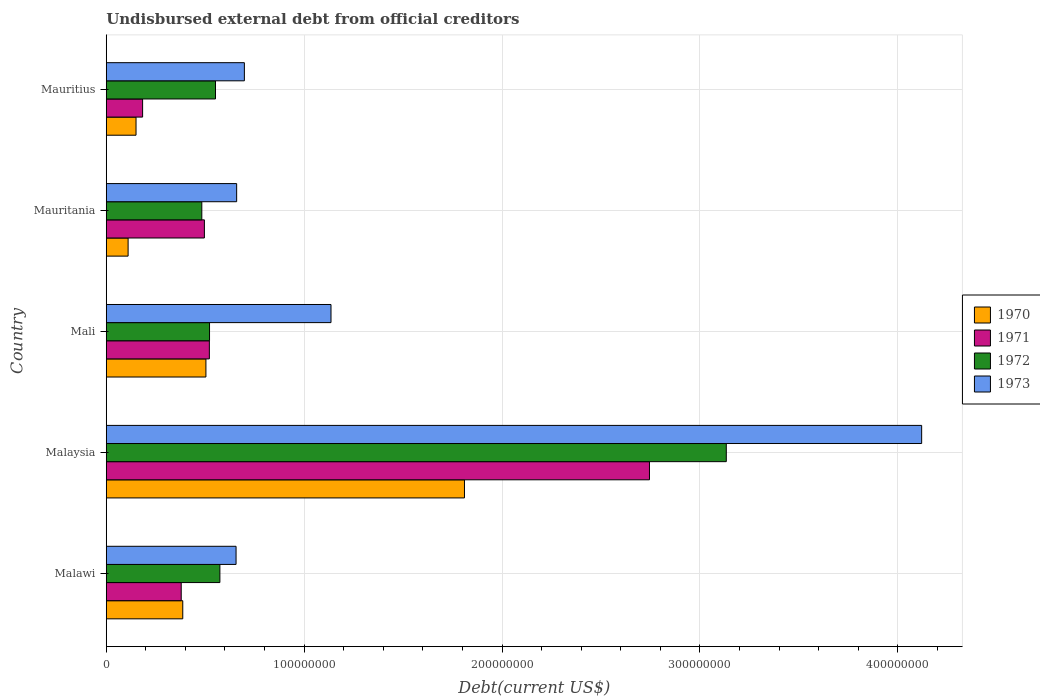How many different coloured bars are there?
Make the answer very short. 4. Are the number of bars per tick equal to the number of legend labels?
Offer a terse response. Yes. Are the number of bars on each tick of the Y-axis equal?
Provide a succinct answer. Yes. How many bars are there on the 1st tick from the bottom?
Offer a terse response. 4. What is the label of the 1st group of bars from the top?
Give a very brief answer. Mauritius. What is the total debt in 1970 in Mauritania?
Provide a succinct answer. 1.10e+07. Across all countries, what is the maximum total debt in 1970?
Give a very brief answer. 1.81e+08. Across all countries, what is the minimum total debt in 1971?
Keep it short and to the point. 1.84e+07. In which country was the total debt in 1973 maximum?
Your answer should be very brief. Malaysia. In which country was the total debt in 1971 minimum?
Your answer should be very brief. Mauritius. What is the total total debt in 1970 in the graph?
Your answer should be very brief. 2.96e+08. What is the difference between the total debt in 1972 in Malawi and that in Mauritius?
Give a very brief answer. 2.22e+06. What is the difference between the total debt in 1971 in Mauritius and the total debt in 1972 in Malawi?
Give a very brief answer. -3.91e+07. What is the average total debt in 1970 per country?
Your answer should be compact. 5.92e+07. What is the difference between the total debt in 1972 and total debt in 1971 in Mauritania?
Your answer should be compact. -1.30e+06. In how many countries, is the total debt in 1970 greater than 120000000 US$?
Offer a very short reply. 1. What is the ratio of the total debt in 1973 in Malawi to that in Malaysia?
Provide a succinct answer. 0.16. Is the total debt in 1973 in Mali less than that in Mauritius?
Provide a succinct answer. No. What is the difference between the highest and the second highest total debt in 1973?
Make the answer very short. 2.98e+08. What is the difference between the highest and the lowest total debt in 1970?
Ensure brevity in your answer.  1.70e+08. In how many countries, is the total debt in 1971 greater than the average total debt in 1971 taken over all countries?
Provide a succinct answer. 1. How many bars are there?
Keep it short and to the point. 20. Are all the bars in the graph horizontal?
Offer a very short reply. Yes. How many countries are there in the graph?
Provide a short and direct response. 5. What is the difference between two consecutive major ticks on the X-axis?
Offer a terse response. 1.00e+08. Are the values on the major ticks of X-axis written in scientific E-notation?
Ensure brevity in your answer.  No. Does the graph contain any zero values?
Provide a succinct answer. No. What is the title of the graph?
Keep it short and to the point. Undisbursed external debt from official creditors. Does "1998" appear as one of the legend labels in the graph?
Ensure brevity in your answer.  No. What is the label or title of the X-axis?
Offer a very short reply. Debt(current US$). What is the label or title of the Y-axis?
Offer a terse response. Country. What is the Debt(current US$) in 1970 in Malawi?
Give a very brief answer. 3.87e+07. What is the Debt(current US$) of 1971 in Malawi?
Keep it short and to the point. 3.79e+07. What is the Debt(current US$) in 1972 in Malawi?
Provide a short and direct response. 5.74e+07. What is the Debt(current US$) of 1973 in Malawi?
Offer a very short reply. 6.56e+07. What is the Debt(current US$) in 1970 in Malaysia?
Keep it short and to the point. 1.81e+08. What is the Debt(current US$) in 1971 in Malaysia?
Your answer should be very brief. 2.74e+08. What is the Debt(current US$) of 1972 in Malaysia?
Your answer should be very brief. 3.13e+08. What is the Debt(current US$) of 1973 in Malaysia?
Provide a succinct answer. 4.12e+08. What is the Debt(current US$) of 1970 in Mali?
Offer a terse response. 5.04e+07. What is the Debt(current US$) in 1971 in Mali?
Offer a very short reply. 5.21e+07. What is the Debt(current US$) of 1972 in Mali?
Provide a short and direct response. 5.22e+07. What is the Debt(current US$) in 1973 in Mali?
Your answer should be very brief. 1.14e+08. What is the Debt(current US$) of 1970 in Mauritania?
Provide a succinct answer. 1.10e+07. What is the Debt(current US$) in 1971 in Mauritania?
Your response must be concise. 4.96e+07. What is the Debt(current US$) of 1972 in Mauritania?
Ensure brevity in your answer.  4.83e+07. What is the Debt(current US$) of 1973 in Mauritania?
Give a very brief answer. 6.59e+07. What is the Debt(current US$) of 1970 in Mauritius?
Offer a very short reply. 1.50e+07. What is the Debt(current US$) of 1971 in Mauritius?
Ensure brevity in your answer.  1.84e+07. What is the Debt(current US$) of 1972 in Mauritius?
Give a very brief answer. 5.52e+07. What is the Debt(current US$) in 1973 in Mauritius?
Make the answer very short. 6.98e+07. Across all countries, what is the maximum Debt(current US$) of 1970?
Provide a succinct answer. 1.81e+08. Across all countries, what is the maximum Debt(current US$) in 1971?
Your response must be concise. 2.74e+08. Across all countries, what is the maximum Debt(current US$) in 1972?
Offer a terse response. 3.13e+08. Across all countries, what is the maximum Debt(current US$) of 1973?
Ensure brevity in your answer.  4.12e+08. Across all countries, what is the minimum Debt(current US$) of 1970?
Keep it short and to the point. 1.10e+07. Across all countries, what is the minimum Debt(current US$) of 1971?
Provide a succinct answer. 1.84e+07. Across all countries, what is the minimum Debt(current US$) in 1972?
Provide a succinct answer. 4.83e+07. Across all countries, what is the minimum Debt(current US$) in 1973?
Give a very brief answer. 6.56e+07. What is the total Debt(current US$) of 1970 in the graph?
Your response must be concise. 2.96e+08. What is the total Debt(current US$) of 1971 in the graph?
Your response must be concise. 4.32e+08. What is the total Debt(current US$) of 1972 in the graph?
Give a very brief answer. 5.26e+08. What is the total Debt(current US$) of 1973 in the graph?
Your answer should be compact. 7.27e+08. What is the difference between the Debt(current US$) in 1970 in Malawi and that in Malaysia?
Provide a succinct answer. -1.42e+08. What is the difference between the Debt(current US$) of 1971 in Malawi and that in Malaysia?
Ensure brevity in your answer.  -2.37e+08. What is the difference between the Debt(current US$) of 1972 in Malawi and that in Malaysia?
Ensure brevity in your answer.  -2.56e+08. What is the difference between the Debt(current US$) of 1973 in Malawi and that in Malaysia?
Offer a terse response. -3.46e+08. What is the difference between the Debt(current US$) of 1970 in Malawi and that in Mali?
Your answer should be compact. -1.17e+07. What is the difference between the Debt(current US$) in 1971 in Malawi and that in Mali?
Ensure brevity in your answer.  -1.42e+07. What is the difference between the Debt(current US$) of 1972 in Malawi and that in Mali?
Offer a terse response. 5.24e+06. What is the difference between the Debt(current US$) in 1973 in Malawi and that in Mali?
Ensure brevity in your answer.  -4.80e+07. What is the difference between the Debt(current US$) of 1970 in Malawi and that in Mauritania?
Offer a very short reply. 2.76e+07. What is the difference between the Debt(current US$) of 1971 in Malawi and that in Mauritania?
Give a very brief answer. -1.17e+07. What is the difference between the Debt(current US$) in 1972 in Malawi and that in Mauritania?
Your answer should be compact. 9.13e+06. What is the difference between the Debt(current US$) in 1973 in Malawi and that in Mauritania?
Your answer should be very brief. -3.01e+05. What is the difference between the Debt(current US$) of 1970 in Malawi and that in Mauritius?
Your response must be concise. 2.36e+07. What is the difference between the Debt(current US$) in 1971 in Malawi and that in Mauritius?
Provide a short and direct response. 1.95e+07. What is the difference between the Debt(current US$) in 1972 in Malawi and that in Mauritius?
Provide a succinct answer. 2.22e+06. What is the difference between the Debt(current US$) in 1973 in Malawi and that in Mauritius?
Your answer should be very brief. -4.20e+06. What is the difference between the Debt(current US$) of 1970 in Malaysia and that in Mali?
Ensure brevity in your answer.  1.31e+08. What is the difference between the Debt(current US$) of 1971 in Malaysia and that in Mali?
Keep it short and to the point. 2.22e+08. What is the difference between the Debt(current US$) in 1972 in Malaysia and that in Mali?
Give a very brief answer. 2.61e+08. What is the difference between the Debt(current US$) in 1973 in Malaysia and that in Mali?
Offer a terse response. 2.98e+08. What is the difference between the Debt(current US$) of 1970 in Malaysia and that in Mauritania?
Provide a succinct answer. 1.70e+08. What is the difference between the Debt(current US$) of 1971 in Malaysia and that in Mauritania?
Provide a short and direct response. 2.25e+08. What is the difference between the Debt(current US$) of 1972 in Malaysia and that in Mauritania?
Your answer should be very brief. 2.65e+08. What is the difference between the Debt(current US$) in 1973 in Malaysia and that in Mauritania?
Provide a short and direct response. 3.46e+08. What is the difference between the Debt(current US$) in 1970 in Malaysia and that in Mauritius?
Offer a terse response. 1.66e+08. What is the difference between the Debt(current US$) of 1971 in Malaysia and that in Mauritius?
Provide a short and direct response. 2.56e+08. What is the difference between the Debt(current US$) in 1972 in Malaysia and that in Mauritius?
Make the answer very short. 2.58e+08. What is the difference between the Debt(current US$) in 1973 in Malaysia and that in Mauritius?
Your answer should be very brief. 3.42e+08. What is the difference between the Debt(current US$) of 1970 in Mali and that in Mauritania?
Your answer should be very brief. 3.93e+07. What is the difference between the Debt(current US$) in 1971 in Mali and that in Mauritania?
Provide a succinct answer. 2.51e+06. What is the difference between the Debt(current US$) in 1972 in Mali and that in Mauritania?
Keep it short and to the point. 3.90e+06. What is the difference between the Debt(current US$) of 1973 in Mali and that in Mauritania?
Make the answer very short. 4.77e+07. What is the difference between the Debt(current US$) of 1970 in Mali and that in Mauritius?
Your answer should be very brief. 3.53e+07. What is the difference between the Debt(current US$) of 1971 in Mali and that in Mauritius?
Give a very brief answer. 3.37e+07. What is the difference between the Debt(current US$) in 1972 in Mali and that in Mauritius?
Make the answer very short. -3.02e+06. What is the difference between the Debt(current US$) of 1973 in Mali and that in Mauritius?
Your answer should be compact. 4.38e+07. What is the difference between the Debt(current US$) in 1970 in Mauritania and that in Mauritius?
Your answer should be very brief. -4.00e+06. What is the difference between the Debt(current US$) of 1971 in Mauritania and that in Mauritius?
Your answer should be very brief. 3.12e+07. What is the difference between the Debt(current US$) in 1972 in Mauritania and that in Mauritius?
Give a very brief answer. -6.91e+06. What is the difference between the Debt(current US$) in 1973 in Mauritania and that in Mauritius?
Offer a terse response. -3.90e+06. What is the difference between the Debt(current US$) in 1970 in Malawi and the Debt(current US$) in 1971 in Malaysia?
Keep it short and to the point. -2.36e+08. What is the difference between the Debt(current US$) in 1970 in Malawi and the Debt(current US$) in 1972 in Malaysia?
Provide a succinct answer. -2.75e+08. What is the difference between the Debt(current US$) of 1970 in Malawi and the Debt(current US$) of 1973 in Malaysia?
Offer a very short reply. -3.73e+08. What is the difference between the Debt(current US$) of 1971 in Malawi and the Debt(current US$) of 1972 in Malaysia?
Give a very brief answer. -2.75e+08. What is the difference between the Debt(current US$) in 1971 in Malawi and the Debt(current US$) in 1973 in Malaysia?
Ensure brevity in your answer.  -3.74e+08. What is the difference between the Debt(current US$) of 1972 in Malawi and the Debt(current US$) of 1973 in Malaysia?
Make the answer very short. -3.55e+08. What is the difference between the Debt(current US$) in 1970 in Malawi and the Debt(current US$) in 1971 in Mali?
Make the answer very short. -1.34e+07. What is the difference between the Debt(current US$) in 1970 in Malawi and the Debt(current US$) in 1972 in Mali?
Your response must be concise. -1.35e+07. What is the difference between the Debt(current US$) in 1970 in Malawi and the Debt(current US$) in 1973 in Mali?
Provide a short and direct response. -7.49e+07. What is the difference between the Debt(current US$) of 1971 in Malawi and the Debt(current US$) of 1972 in Mali?
Offer a very short reply. -1.43e+07. What is the difference between the Debt(current US$) in 1971 in Malawi and the Debt(current US$) in 1973 in Mali?
Provide a short and direct response. -7.57e+07. What is the difference between the Debt(current US$) in 1972 in Malawi and the Debt(current US$) in 1973 in Mali?
Provide a succinct answer. -5.61e+07. What is the difference between the Debt(current US$) in 1970 in Malawi and the Debt(current US$) in 1971 in Mauritania?
Your answer should be very brief. -1.09e+07. What is the difference between the Debt(current US$) in 1970 in Malawi and the Debt(current US$) in 1972 in Mauritania?
Provide a short and direct response. -9.63e+06. What is the difference between the Debt(current US$) in 1970 in Malawi and the Debt(current US$) in 1973 in Mauritania?
Your response must be concise. -2.72e+07. What is the difference between the Debt(current US$) of 1971 in Malawi and the Debt(current US$) of 1972 in Mauritania?
Provide a succinct answer. -1.04e+07. What is the difference between the Debt(current US$) of 1971 in Malawi and the Debt(current US$) of 1973 in Mauritania?
Keep it short and to the point. -2.80e+07. What is the difference between the Debt(current US$) in 1972 in Malawi and the Debt(current US$) in 1973 in Mauritania?
Offer a very short reply. -8.47e+06. What is the difference between the Debt(current US$) of 1970 in Malawi and the Debt(current US$) of 1971 in Mauritius?
Your answer should be compact. 2.03e+07. What is the difference between the Debt(current US$) in 1970 in Malawi and the Debt(current US$) in 1972 in Mauritius?
Give a very brief answer. -1.65e+07. What is the difference between the Debt(current US$) in 1970 in Malawi and the Debt(current US$) in 1973 in Mauritius?
Offer a very short reply. -3.11e+07. What is the difference between the Debt(current US$) of 1971 in Malawi and the Debt(current US$) of 1972 in Mauritius?
Provide a short and direct response. -1.73e+07. What is the difference between the Debt(current US$) of 1971 in Malawi and the Debt(current US$) of 1973 in Mauritius?
Offer a very short reply. -3.19e+07. What is the difference between the Debt(current US$) in 1972 in Malawi and the Debt(current US$) in 1973 in Mauritius?
Give a very brief answer. -1.24e+07. What is the difference between the Debt(current US$) of 1970 in Malaysia and the Debt(current US$) of 1971 in Mali?
Provide a succinct answer. 1.29e+08. What is the difference between the Debt(current US$) in 1970 in Malaysia and the Debt(current US$) in 1972 in Mali?
Your response must be concise. 1.29e+08. What is the difference between the Debt(current US$) in 1970 in Malaysia and the Debt(current US$) in 1973 in Mali?
Ensure brevity in your answer.  6.74e+07. What is the difference between the Debt(current US$) of 1971 in Malaysia and the Debt(current US$) of 1972 in Mali?
Ensure brevity in your answer.  2.22e+08. What is the difference between the Debt(current US$) in 1971 in Malaysia and the Debt(current US$) in 1973 in Mali?
Offer a very short reply. 1.61e+08. What is the difference between the Debt(current US$) of 1972 in Malaysia and the Debt(current US$) of 1973 in Mali?
Give a very brief answer. 2.00e+08. What is the difference between the Debt(current US$) of 1970 in Malaysia and the Debt(current US$) of 1971 in Mauritania?
Ensure brevity in your answer.  1.31e+08. What is the difference between the Debt(current US$) in 1970 in Malaysia and the Debt(current US$) in 1972 in Mauritania?
Give a very brief answer. 1.33e+08. What is the difference between the Debt(current US$) of 1970 in Malaysia and the Debt(current US$) of 1973 in Mauritania?
Your answer should be very brief. 1.15e+08. What is the difference between the Debt(current US$) in 1971 in Malaysia and the Debt(current US$) in 1972 in Mauritania?
Give a very brief answer. 2.26e+08. What is the difference between the Debt(current US$) of 1971 in Malaysia and the Debt(current US$) of 1973 in Mauritania?
Provide a succinct answer. 2.09e+08. What is the difference between the Debt(current US$) in 1972 in Malaysia and the Debt(current US$) in 1973 in Mauritania?
Make the answer very short. 2.47e+08. What is the difference between the Debt(current US$) in 1970 in Malaysia and the Debt(current US$) in 1971 in Mauritius?
Your response must be concise. 1.63e+08. What is the difference between the Debt(current US$) of 1970 in Malaysia and the Debt(current US$) of 1972 in Mauritius?
Ensure brevity in your answer.  1.26e+08. What is the difference between the Debt(current US$) of 1970 in Malaysia and the Debt(current US$) of 1973 in Mauritius?
Your answer should be compact. 1.11e+08. What is the difference between the Debt(current US$) of 1971 in Malaysia and the Debt(current US$) of 1972 in Mauritius?
Provide a succinct answer. 2.19e+08. What is the difference between the Debt(current US$) in 1971 in Malaysia and the Debt(current US$) in 1973 in Mauritius?
Your answer should be compact. 2.05e+08. What is the difference between the Debt(current US$) in 1972 in Malaysia and the Debt(current US$) in 1973 in Mauritius?
Offer a terse response. 2.44e+08. What is the difference between the Debt(current US$) in 1970 in Mali and the Debt(current US$) in 1971 in Mauritania?
Make the answer very short. 7.72e+05. What is the difference between the Debt(current US$) of 1970 in Mali and the Debt(current US$) of 1972 in Mauritania?
Your response must be concise. 2.07e+06. What is the difference between the Debt(current US$) in 1970 in Mali and the Debt(current US$) in 1973 in Mauritania?
Your answer should be very brief. -1.55e+07. What is the difference between the Debt(current US$) of 1971 in Mali and the Debt(current US$) of 1972 in Mauritania?
Offer a terse response. 3.81e+06. What is the difference between the Debt(current US$) of 1971 in Mali and the Debt(current US$) of 1973 in Mauritania?
Your answer should be very brief. -1.38e+07. What is the difference between the Debt(current US$) in 1972 in Mali and the Debt(current US$) in 1973 in Mauritania?
Offer a terse response. -1.37e+07. What is the difference between the Debt(current US$) in 1970 in Mali and the Debt(current US$) in 1971 in Mauritius?
Give a very brief answer. 3.20e+07. What is the difference between the Debt(current US$) of 1970 in Mali and the Debt(current US$) of 1972 in Mauritius?
Give a very brief answer. -4.84e+06. What is the difference between the Debt(current US$) of 1970 in Mali and the Debt(current US$) of 1973 in Mauritius?
Your answer should be compact. -1.94e+07. What is the difference between the Debt(current US$) of 1971 in Mali and the Debt(current US$) of 1972 in Mauritius?
Offer a terse response. -3.10e+06. What is the difference between the Debt(current US$) in 1971 in Mali and the Debt(current US$) in 1973 in Mauritius?
Give a very brief answer. -1.77e+07. What is the difference between the Debt(current US$) of 1972 in Mali and the Debt(current US$) of 1973 in Mauritius?
Provide a succinct answer. -1.76e+07. What is the difference between the Debt(current US$) in 1970 in Mauritania and the Debt(current US$) in 1971 in Mauritius?
Offer a very short reply. -7.33e+06. What is the difference between the Debt(current US$) in 1970 in Mauritania and the Debt(current US$) in 1972 in Mauritius?
Give a very brief answer. -4.42e+07. What is the difference between the Debt(current US$) in 1970 in Mauritania and the Debt(current US$) in 1973 in Mauritius?
Provide a succinct answer. -5.88e+07. What is the difference between the Debt(current US$) of 1971 in Mauritania and the Debt(current US$) of 1972 in Mauritius?
Make the answer very short. -5.62e+06. What is the difference between the Debt(current US$) of 1971 in Mauritania and the Debt(current US$) of 1973 in Mauritius?
Make the answer very short. -2.02e+07. What is the difference between the Debt(current US$) in 1972 in Mauritania and the Debt(current US$) in 1973 in Mauritius?
Give a very brief answer. -2.15e+07. What is the average Debt(current US$) in 1970 per country?
Ensure brevity in your answer.  5.92e+07. What is the average Debt(current US$) of 1971 per country?
Your answer should be very brief. 8.65e+07. What is the average Debt(current US$) of 1972 per country?
Keep it short and to the point. 1.05e+08. What is the average Debt(current US$) of 1973 per country?
Make the answer very short. 1.45e+08. What is the difference between the Debt(current US$) of 1970 and Debt(current US$) of 1971 in Malawi?
Keep it short and to the point. 7.85e+05. What is the difference between the Debt(current US$) of 1970 and Debt(current US$) of 1972 in Malawi?
Your answer should be very brief. -1.88e+07. What is the difference between the Debt(current US$) of 1970 and Debt(current US$) of 1973 in Malawi?
Offer a terse response. -2.69e+07. What is the difference between the Debt(current US$) of 1971 and Debt(current US$) of 1972 in Malawi?
Provide a short and direct response. -1.95e+07. What is the difference between the Debt(current US$) in 1971 and Debt(current US$) in 1973 in Malawi?
Your answer should be very brief. -2.77e+07. What is the difference between the Debt(current US$) in 1972 and Debt(current US$) in 1973 in Malawi?
Offer a very short reply. -8.17e+06. What is the difference between the Debt(current US$) in 1970 and Debt(current US$) in 1971 in Malaysia?
Make the answer very short. -9.35e+07. What is the difference between the Debt(current US$) in 1970 and Debt(current US$) in 1972 in Malaysia?
Offer a very short reply. -1.32e+08. What is the difference between the Debt(current US$) in 1970 and Debt(current US$) in 1973 in Malaysia?
Offer a terse response. -2.31e+08. What is the difference between the Debt(current US$) in 1971 and Debt(current US$) in 1972 in Malaysia?
Make the answer very short. -3.88e+07. What is the difference between the Debt(current US$) of 1971 and Debt(current US$) of 1973 in Malaysia?
Your answer should be compact. -1.38e+08. What is the difference between the Debt(current US$) of 1972 and Debt(current US$) of 1973 in Malaysia?
Offer a very short reply. -9.87e+07. What is the difference between the Debt(current US$) of 1970 and Debt(current US$) of 1971 in Mali?
Keep it short and to the point. -1.74e+06. What is the difference between the Debt(current US$) in 1970 and Debt(current US$) in 1972 in Mali?
Keep it short and to the point. -1.82e+06. What is the difference between the Debt(current US$) of 1970 and Debt(current US$) of 1973 in Mali?
Your response must be concise. -6.32e+07. What is the difference between the Debt(current US$) in 1971 and Debt(current US$) in 1972 in Mali?
Give a very brief answer. -8.30e+04. What is the difference between the Debt(current US$) in 1971 and Debt(current US$) in 1973 in Mali?
Keep it short and to the point. -6.15e+07. What is the difference between the Debt(current US$) of 1972 and Debt(current US$) of 1973 in Mali?
Your response must be concise. -6.14e+07. What is the difference between the Debt(current US$) of 1970 and Debt(current US$) of 1971 in Mauritania?
Provide a short and direct response. -3.85e+07. What is the difference between the Debt(current US$) in 1970 and Debt(current US$) in 1972 in Mauritania?
Make the answer very short. -3.72e+07. What is the difference between the Debt(current US$) of 1970 and Debt(current US$) of 1973 in Mauritania?
Provide a succinct answer. -5.49e+07. What is the difference between the Debt(current US$) in 1971 and Debt(current US$) in 1972 in Mauritania?
Keep it short and to the point. 1.30e+06. What is the difference between the Debt(current US$) in 1971 and Debt(current US$) in 1973 in Mauritania?
Keep it short and to the point. -1.63e+07. What is the difference between the Debt(current US$) of 1972 and Debt(current US$) of 1973 in Mauritania?
Your answer should be compact. -1.76e+07. What is the difference between the Debt(current US$) of 1970 and Debt(current US$) of 1971 in Mauritius?
Give a very brief answer. -3.32e+06. What is the difference between the Debt(current US$) of 1970 and Debt(current US$) of 1972 in Mauritius?
Offer a very short reply. -4.02e+07. What is the difference between the Debt(current US$) of 1970 and Debt(current US$) of 1973 in Mauritius?
Your answer should be compact. -5.47e+07. What is the difference between the Debt(current US$) in 1971 and Debt(current US$) in 1972 in Mauritius?
Your response must be concise. -3.68e+07. What is the difference between the Debt(current US$) in 1971 and Debt(current US$) in 1973 in Mauritius?
Give a very brief answer. -5.14e+07. What is the difference between the Debt(current US$) in 1972 and Debt(current US$) in 1973 in Mauritius?
Ensure brevity in your answer.  -1.46e+07. What is the ratio of the Debt(current US$) in 1970 in Malawi to that in Malaysia?
Make the answer very short. 0.21. What is the ratio of the Debt(current US$) of 1971 in Malawi to that in Malaysia?
Make the answer very short. 0.14. What is the ratio of the Debt(current US$) in 1972 in Malawi to that in Malaysia?
Provide a short and direct response. 0.18. What is the ratio of the Debt(current US$) of 1973 in Malawi to that in Malaysia?
Provide a short and direct response. 0.16. What is the ratio of the Debt(current US$) of 1970 in Malawi to that in Mali?
Offer a terse response. 0.77. What is the ratio of the Debt(current US$) of 1971 in Malawi to that in Mali?
Your response must be concise. 0.73. What is the ratio of the Debt(current US$) in 1972 in Malawi to that in Mali?
Your response must be concise. 1.1. What is the ratio of the Debt(current US$) in 1973 in Malawi to that in Mali?
Provide a short and direct response. 0.58. What is the ratio of the Debt(current US$) in 1970 in Malawi to that in Mauritania?
Your answer should be compact. 3.5. What is the ratio of the Debt(current US$) of 1971 in Malawi to that in Mauritania?
Give a very brief answer. 0.76. What is the ratio of the Debt(current US$) of 1972 in Malawi to that in Mauritania?
Keep it short and to the point. 1.19. What is the ratio of the Debt(current US$) in 1973 in Malawi to that in Mauritania?
Your answer should be compact. 1. What is the ratio of the Debt(current US$) of 1970 in Malawi to that in Mauritius?
Your answer should be very brief. 2.57. What is the ratio of the Debt(current US$) of 1971 in Malawi to that in Mauritius?
Provide a short and direct response. 2.06. What is the ratio of the Debt(current US$) of 1972 in Malawi to that in Mauritius?
Your answer should be very brief. 1.04. What is the ratio of the Debt(current US$) in 1973 in Malawi to that in Mauritius?
Offer a very short reply. 0.94. What is the ratio of the Debt(current US$) of 1970 in Malaysia to that in Mali?
Make the answer very short. 3.59. What is the ratio of the Debt(current US$) of 1971 in Malaysia to that in Mali?
Offer a very short reply. 5.27. What is the ratio of the Debt(current US$) of 1972 in Malaysia to that in Mali?
Provide a short and direct response. 6. What is the ratio of the Debt(current US$) of 1973 in Malaysia to that in Mali?
Your answer should be compact. 3.63. What is the ratio of the Debt(current US$) in 1970 in Malaysia to that in Mauritania?
Ensure brevity in your answer.  16.39. What is the ratio of the Debt(current US$) in 1971 in Malaysia to that in Mauritania?
Provide a succinct answer. 5.54. What is the ratio of the Debt(current US$) of 1972 in Malaysia to that in Mauritania?
Your response must be concise. 6.49. What is the ratio of the Debt(current US$) in 1973 in Malaysia to that in Mauritania?
Give a very brief answer. 6.25. What is the ratio of the Debt(current US$) in 1970 in Malaysia to that in Mauritius?
Your answer should be compact. 12.03. What is the ratio of the Debt(current US$) in 1971 in Malaysia to that in Mauritius?
Your answer should be compact. 14.94. What is the ratio of the Debt(current US$) in 1972 in Malaysia to that in Mauritius?
Your answer should be very brief. 5.68. What is the ratio of the Debt(current US$) in 1973 in Malaysia to that in Mauritius?
Provide a succinct answer. 5.9. What is the ratio of the Debt(current US$) in 1970 in Mali to that in Mauritania?
Ensure brevity in your answer.  4.56. What is the ratio of the Debt(current US$) in 1971 in Mali to that in Mauritania?
Make the answer very short. 1.05. What is the ratio of the Debt(current US$) in 1972 in Mali to that in Mauritania?
Keep it short and to the point. 1.08. What is the ratio of the Debt(current US$) in 1973 in Mali to that in Mauritania?
Keep it short and to the point. 1.72. What is the ratio of the Debt(current US$) of 1970 in Mali to that in Mauritius?
Provide a succinct answer. 3.35. What is the ratio of the Debt(current US$) of 1971 in Mali to that in Mauritius?
Your answer should be very brief. 2.84. What is the ratio of the Debt(current US$) in 1972 in Mali to that in Mauritius?
Make the answer very short. 0.95. What is the ratio of the Debt(current US$) of 1973 in Mali to that in Mauritius?
Provide a short and direct response. 1.63. What is the ratio of the Debt(current US$) in 1970 in Mauritania to that in Mauritius?
Make the answer very short. 0.73. What is the ratio of the Debt(current US$) in 1971 in Mauritania to that in Mauritius?
Offer a terse response. 2.7. What is the ratio of the Debt(current US$) in 1972 in Mauritania to that in Mauritius?
Ensure brevity in your answer.  0.87. What is the ratio of the Debt(current US$) in 1973 in Mauritania to that in Mauritius?
Give a very brief answer. 0.94. What is the difference between the highest and the second highest Debt(current US$) of 1970?
Provide a succinct answer. 1.31e+08. What is the difference between the highest and the second highest Debt(current US$) of 1971?
Your answer should be compact. 2.22e+08. What is the difference between the highest and the second highest Debt(current US$) in 1972?
Your response must be concise. 2.56e+08. What is the difference between the highest and the second highest Debt(current US$) in 1973?
Offer a terse response. 2.98e+08. What is the difference between the highest and the lowest Debt(current US$) in 1970?
Give a very brief answer. 1.70e+08. What is the difference between the highest and the lowest Debt(current US$) in 1971?
Provide a succinct answer. 2.56e+08. What is the difference between the highest and the lowest Debt(current US$) in 1972?
Offer a very short reply. 2.65e+08. What is the difference between the highest and the lowest Debt(current US$) in 1973?
Your answer should be compact. 3.46e+08. 